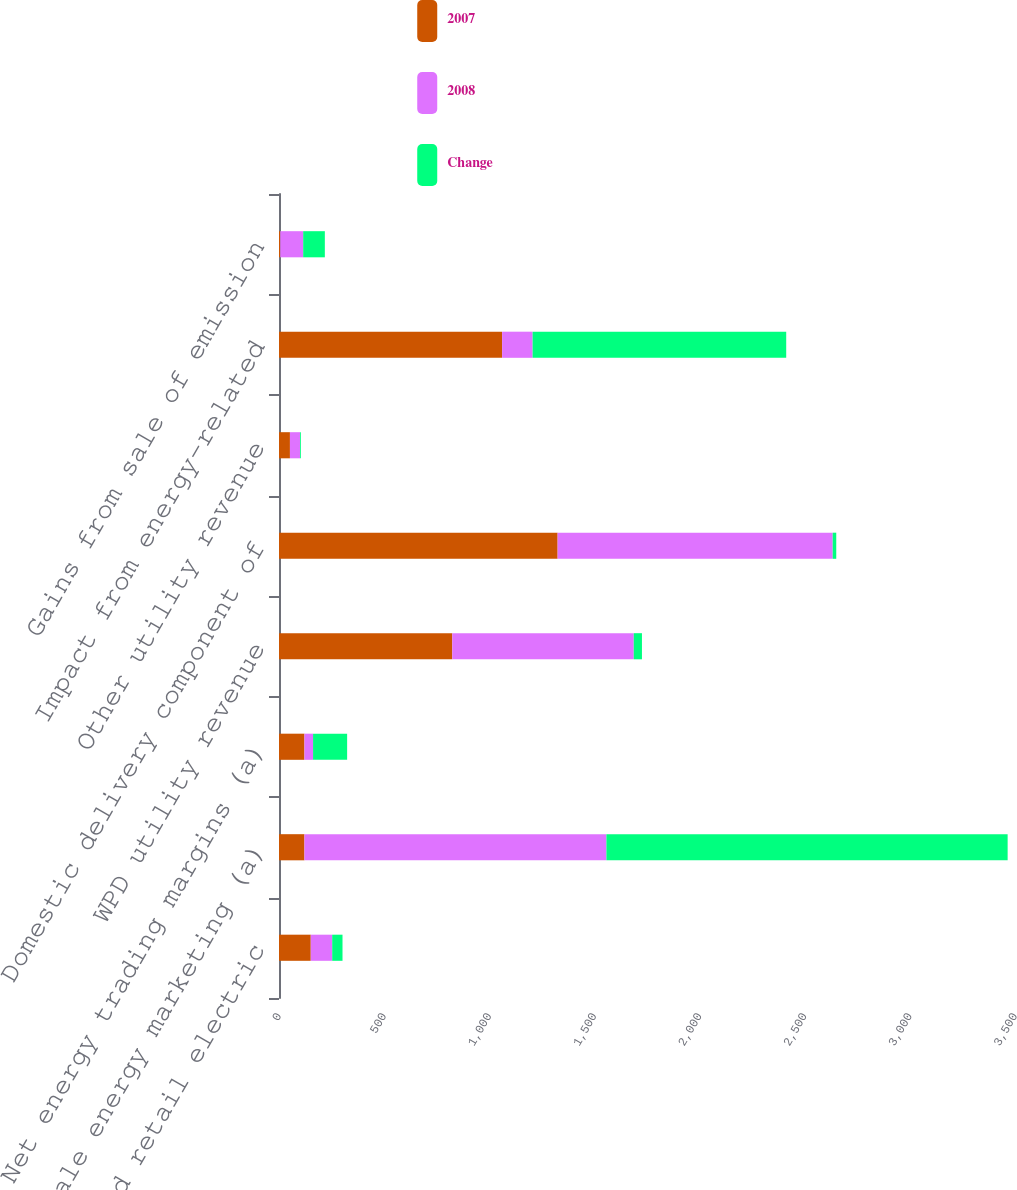<chart> <loc_0><loc_0><loc_500><loc_500><stacked_bar_chart><ecel><fcel>Unregulated retail electric<fcel>Wholesale energy marketing (a)<fcel>Net energy trading margins (a)<fcel>WPD utility revenue<fcel>Domestic delivery component of<fcel>Other utility revenue<fcel>Impact from energy-related<fcel>Gains from sale of emission<nl><fcel>2007<fcel>151<fcel>121<fcel>121<fcel>824<fcel>1325<fcel>52<fcel>1061<fcel>6<nl><fcel>2008<fcel>102<fcel>1436<fcel>41<fcel>863<fcel>1308<fcel>48<fcel>145<fcel>109<nl><fcel>Change<fcel>49<fcel>1908<fcel>162<fcel>39<fcel>17<fcel>4<fcel>1206<fcel>103<nl></chart> 